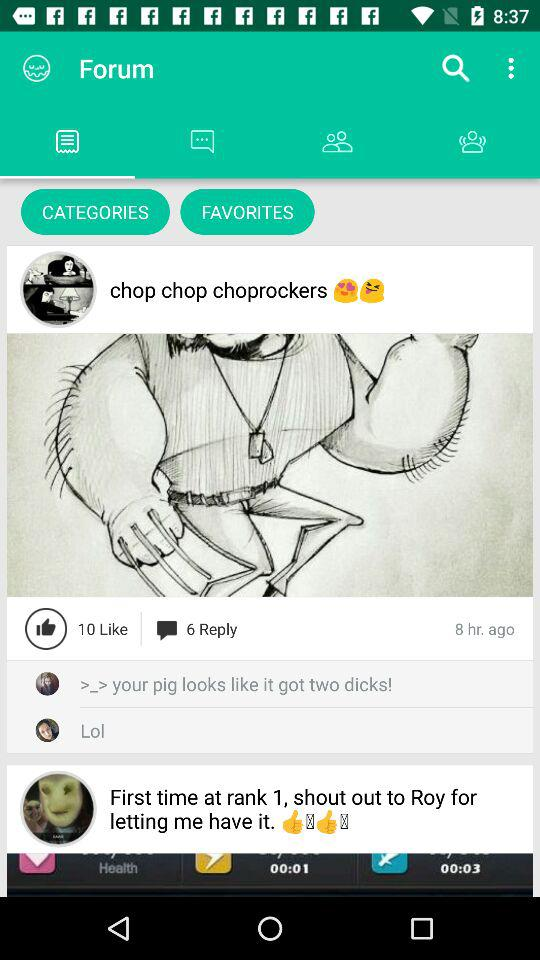How many replies are there on the post "chop chop choprockers"? There are 6 replies on the post "chop chop choprockers". 